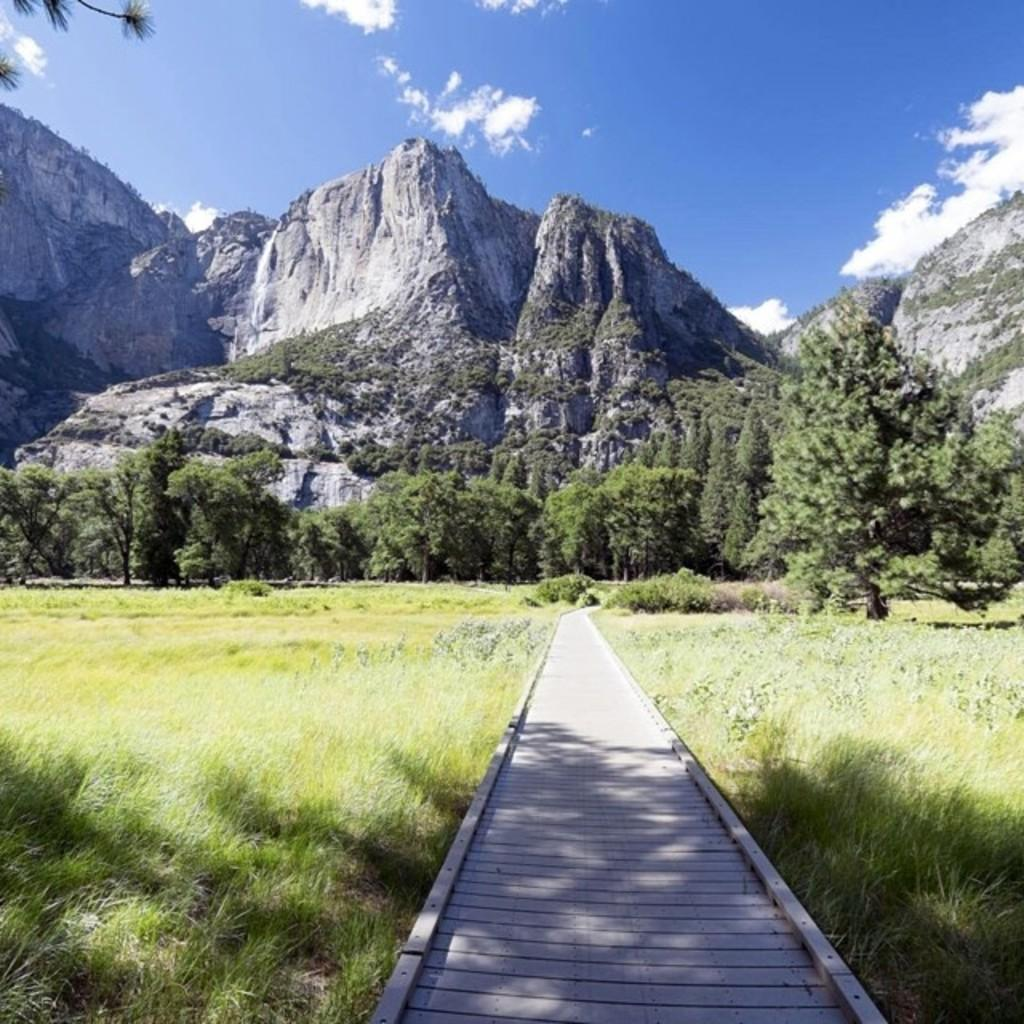What type of path is visible in the image? There is a wooden path in the image. What can be seen on both sides of the path? There is grass on both sides of the path. What is visible in the background of the image? There are trees, hills, and the sky in the background of the image. What is the condition of the sky in the image? Clouds are present in the sky. What type of leather is used to make the clouds in the image? There is no leather present in the image, as the clouds are a natural atmospheric phenomenon. 